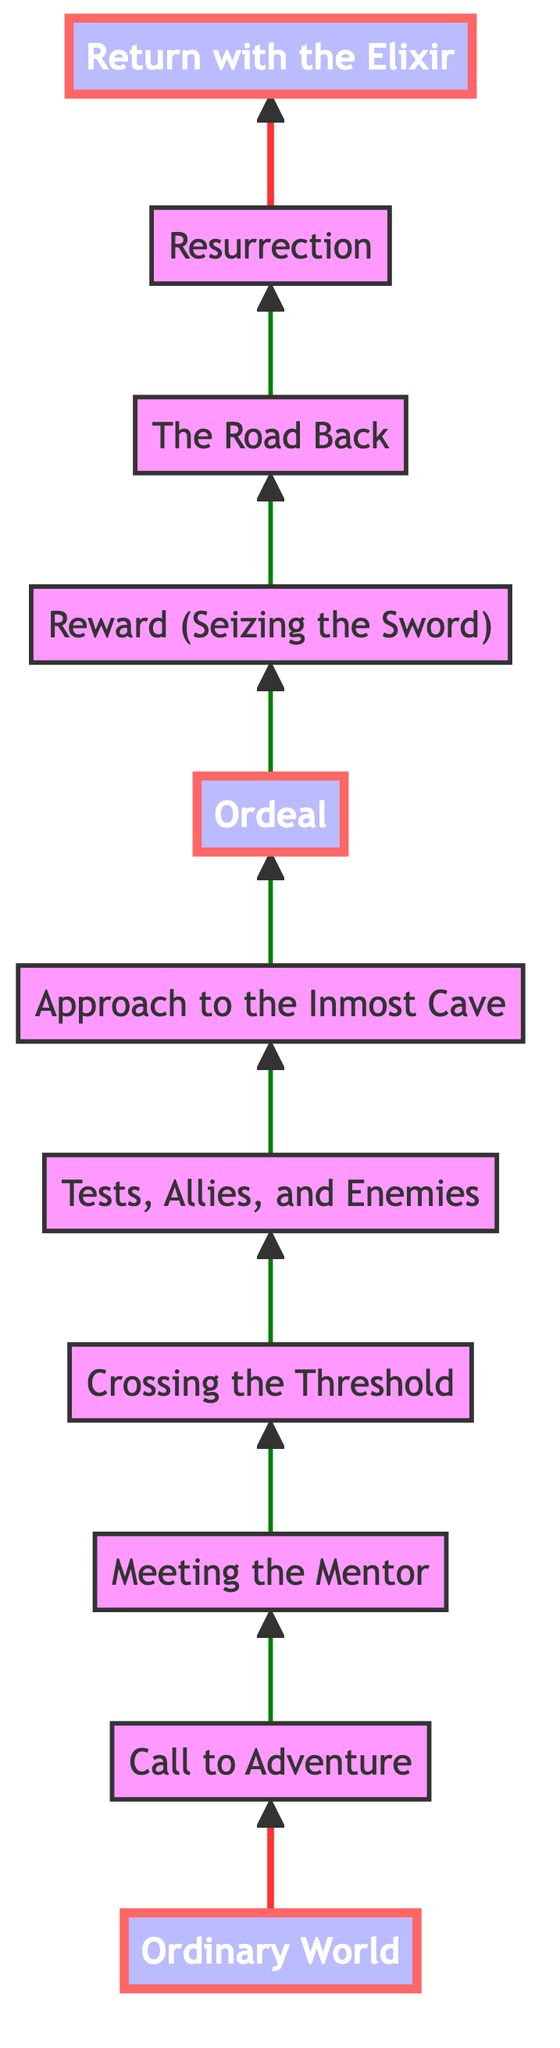What is the first node in the diagram? The first node, located at the bottom of the flowchart, is the "Ordinary World." This is the starting point of the hero's journey.
Answer: Ordinary World How many total nodes are there in the diagram? The diagram contains a total of eleven nodes that represent different stages in the hero's journey.
Answer: Eleven Which node directly follows the "Crossing the Threshold"? The node that follows "Crossing the Threshold" is "Tests, Allies, and Enemies." This represents the challenges the hero faces after entering the new world.
Answer: Tests, Allies, and Enemies What is the last node in the diagram? The last node at the top of the flowchart is "Return with the Elixir." This is the final stage of the hero's journey where the hero returns transformed.
Answer: Return with the Elixir What are the two special nodes highlighted in the diagram? The special nodes are "Ordeal" and "Return with the Elixir." These key moments indicate pivotal points in the hero's journey.
Answer: Ordeal, Return with the Elixir What is the connection between "Resurrection" and "The Road Back"? "Resurrection" follows "The Road Back," suggesting that after the hero returns to their ordinary world, they face a final challenge that requires demonstrating growth.
Answer: Resurrection How many edges connect to the "Ordeal" node? The "Ordeal" node has one incoming edge from "Approach to the Inmost Cave" and one outgoing edge to "Reward (Seizing the Sword)," resulting in two edges connected to it.
Answer: Two In what phase does the hero encounter a mentor? The hero encounters a mentor in the "Meeting the Mentor" phase, which follows the "Call to Adventure," providing essential guidance for the journey.
Answer: Meeting the Mentor Which node represents the hero’s greatest challenge? The node labeled "Ordeal" represents the hero's greatest challenge, marking the central crisis of their journey.
Answer: Ordeal 